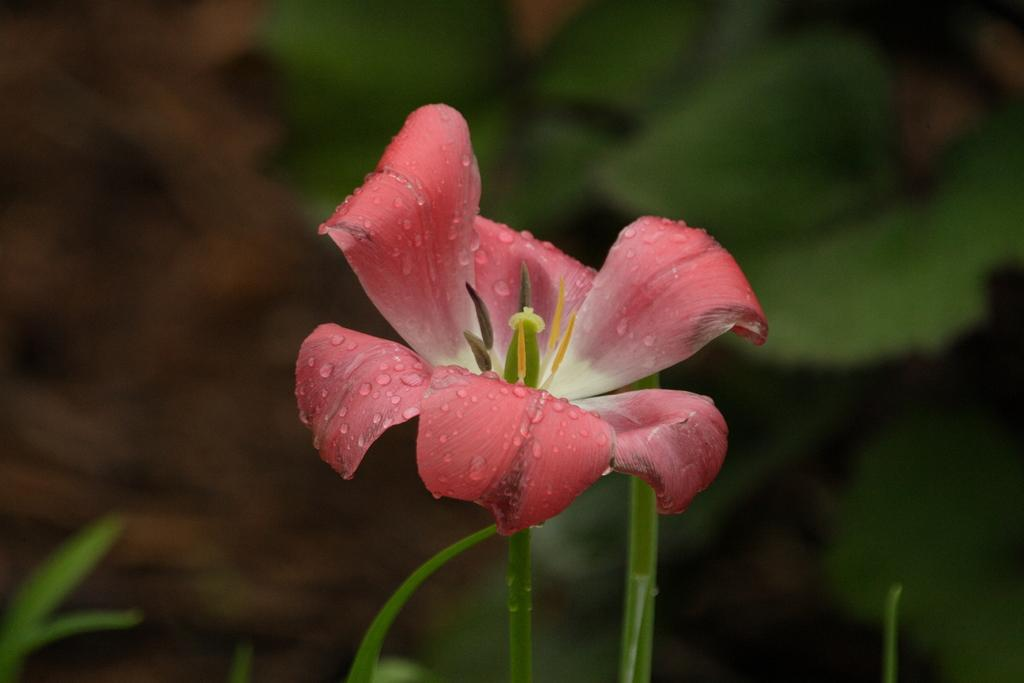What is the main subject of the image? There is a flower in the image. What can be seen in the background of the image? There are plants in the background of the image. How would you describe the quality of the image? The image is blurry. What type of ray can be seen swimming in the image? There is no ray present in the image; it features a flower and plants in the background. What type of wire is visible in the image? There is no wire present in the image. 